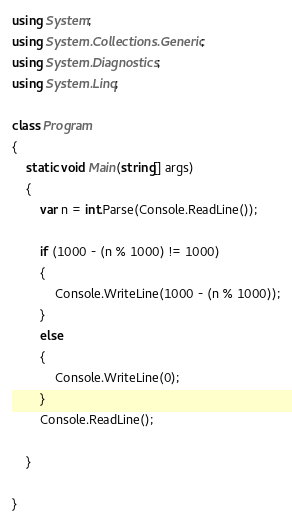Convert code to text. <code><loc_0><loc_0><loc_500><loc_500><_C#_>using System;
using System.Collections.Generic;
using System.Diagnostics;
using System.Linq;

class Program
{
    static void Main(string[] args)
    {
        var n = int.Parse(Console.ReadLine());

        if (1000 - (n % 1000) != 1000)
        {
            Console.WriteLine(1000 - (n % 1000));
        }
        else
        {
            Console.WriteLine(0);
        }
        Console.ReadLine();

    }

}</code> 